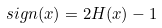<formula> <loc_0><loc_0><loc_500><loc_500>s i g n ( x ) = 2 H ( x ) - 1</formula> 